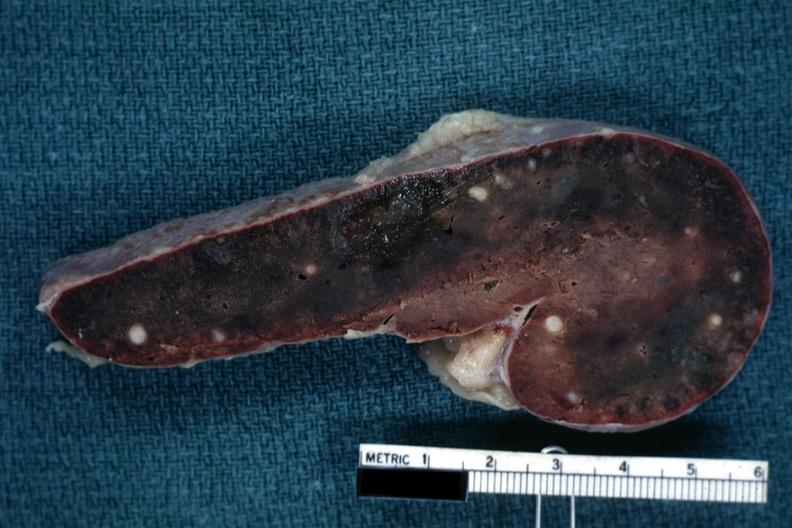what cut surface congested parenchyma with obvious granulomas?
Answer the question using a single word or phrase. Fixed tissue 